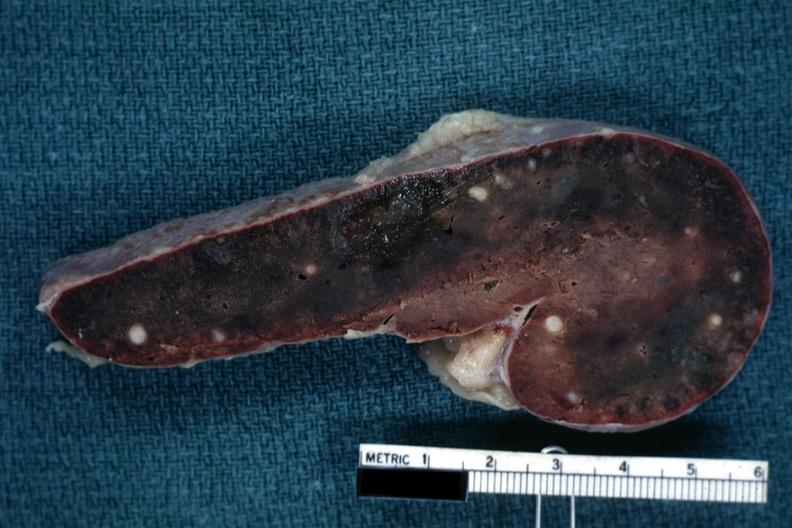what cut surface congested parenchyma with obvious granulomas?
Answer the question using a single word or phrase. Fixed tissue 